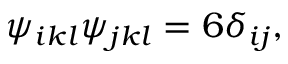<formula> <loc_0><loc_0><loc_500><loc_500>\psi _ { i k l } \psi _ { j k l } = 6 \delta _ { i j } ,</formula> 